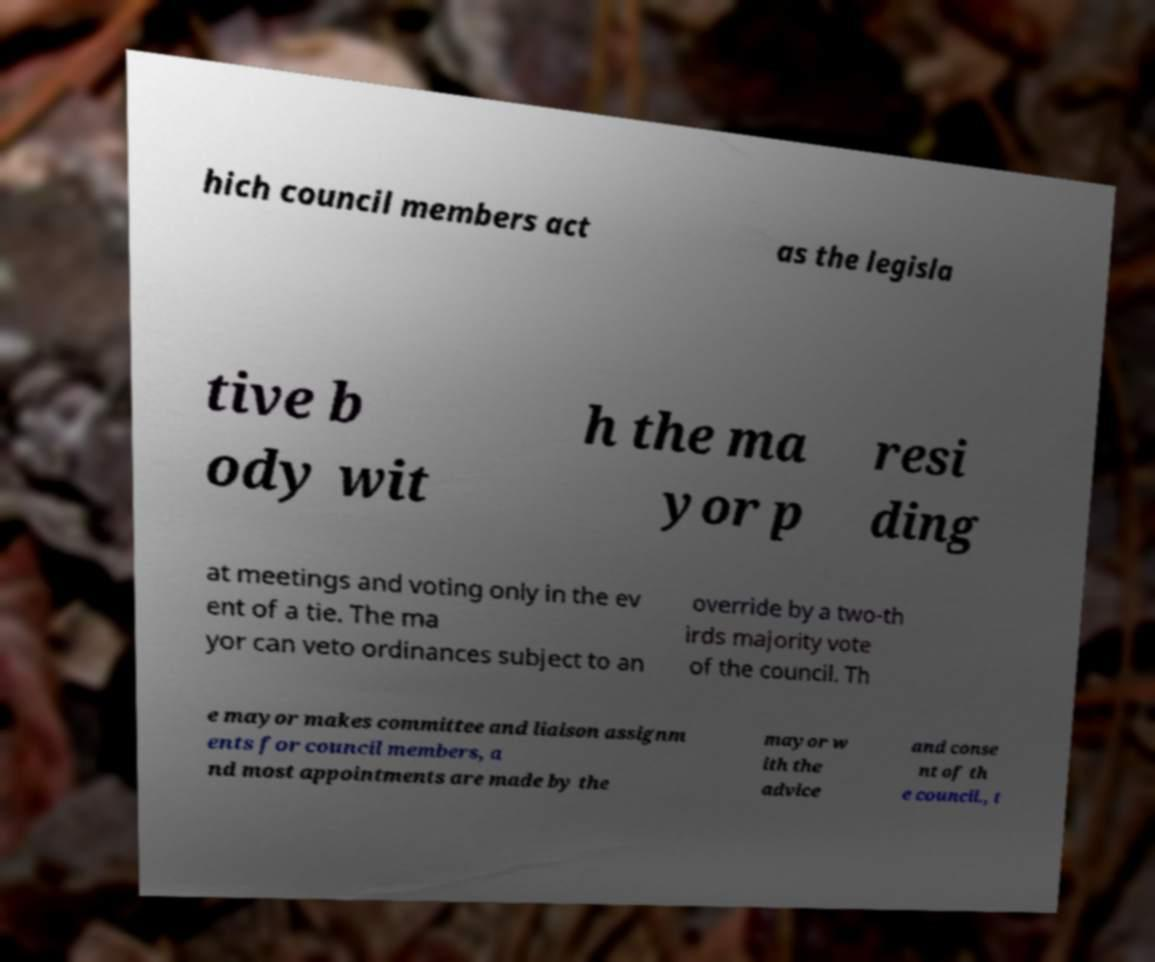Can you accurately transcribe the text from the provided image for me? hich council members act as the legisla tive b ody wit h the ma yor p resi ding at meetings and voting only in the ev ent of a tie. The ma yor can veto ordinances subject to an override by a two-th irds majority vote of the council. Th e mayor makes committee and liaison assignm ents for council members, a nd most appointments are made by the mayor w ith the advice and conse nt of th e council., t 